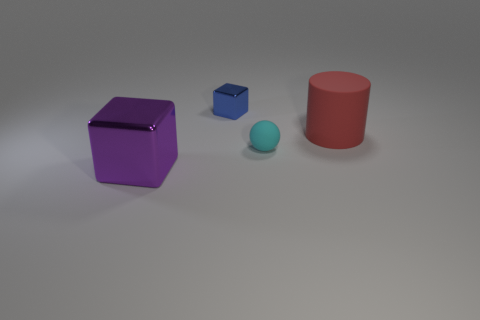Is there any other thing of the same color as the small sphere?
Give a very brief answer. No. What size is the cyan ball that is made of the same material as the red cylinder?
Your answer should be very brief. Small. What is the material of the small blue thing?
Give a very brief answer. Metal. How many red things are the same size as the purple thing?
Offer a terse response. 1. Are there any blue objects that have the same shape as the tiny cyan object?
Provide a short and direct response. No. What is the color of the rubber ball that is the same size as the blue thing?
Your response must be concise. Cyan. What color is the large thing that is to the right of the metal object right of the purple metallic cube?
Your answer should be very brief. Red. There is a metallic block that is left of the blue metal block; does it have the same color as the big matte thing?
Provide a short and direct response. No. What is the shape of the large red matte object behind the block that is to the left of the metallic thing that is behind the large shiny block?
Offer a very short reply. Cylinder. How many large objects are to the right of the block right of the big purple metallic cube?
Give a very brief answer. 1. 